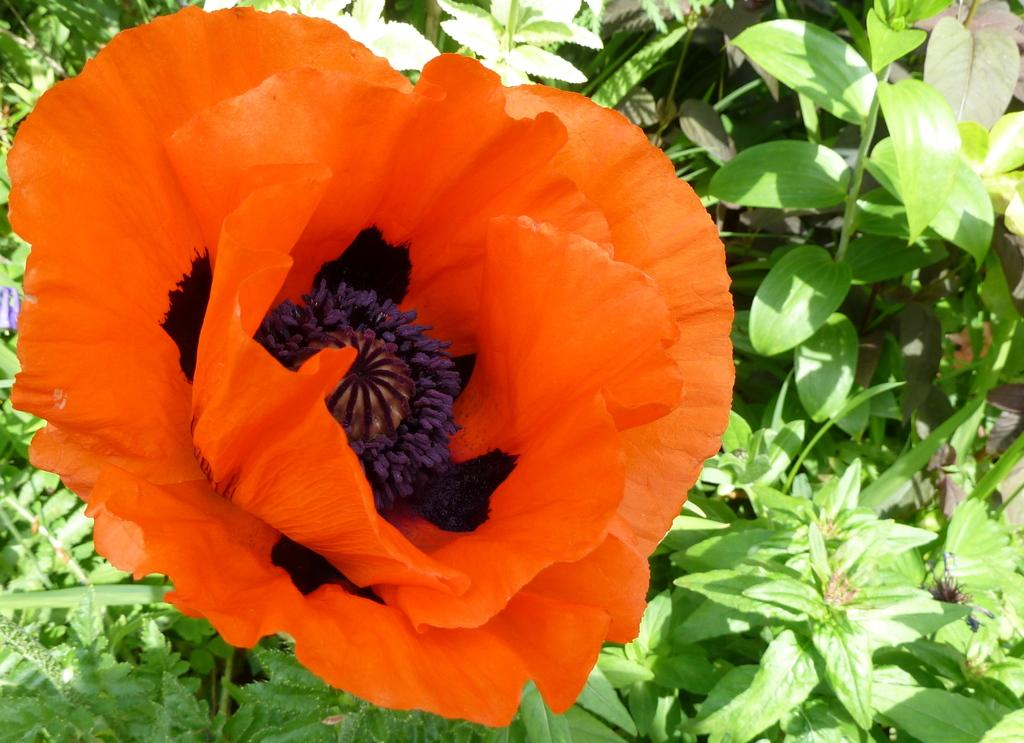What color is the flower in the image? The flower in the image is orange. What other types of plants can be seen in the image? There are plants visible in the image. What type of ground cover is present in the image? There is grass in the image. What part of the plants can be seen at the bottom of the image? Leaves are visible at the bottom of the image. Is there a person standing next to the flower in the image? There is no person visible in the image; it only features plants and flowers. 